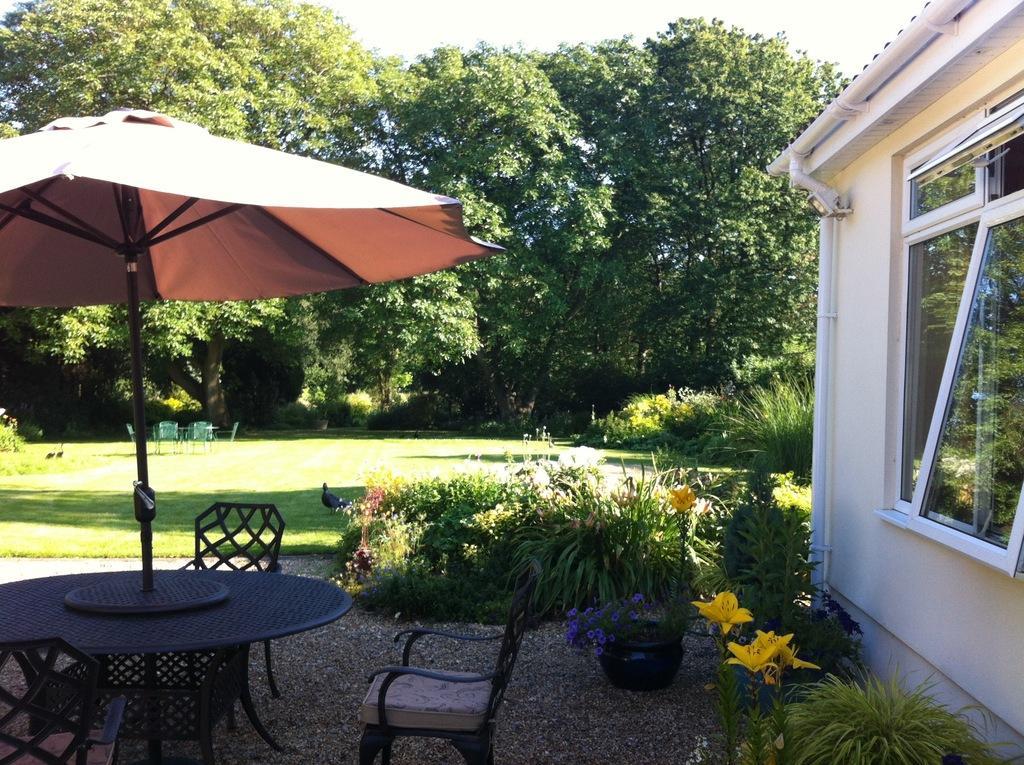Please provide a concise description of this image. In this image there is a table and three chairs. There are many flower plants at the left of the table and a building at the left. Behind there is grass and many trees. It's a sunny day. 